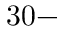Convert formula to latex. <formula><loc_0><loc_0><loc_500><loc_500>3 0 -</formula> 